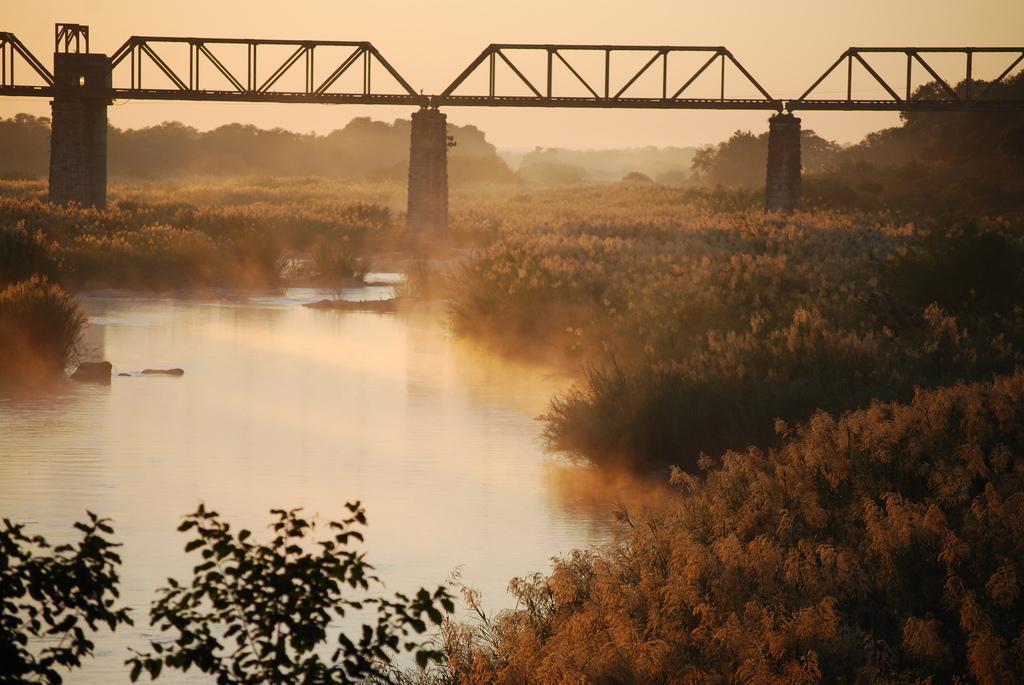Could you give a brief overview of what you see in this image? In this picture we can see water, few plants and trees, also we can see a bridge. 